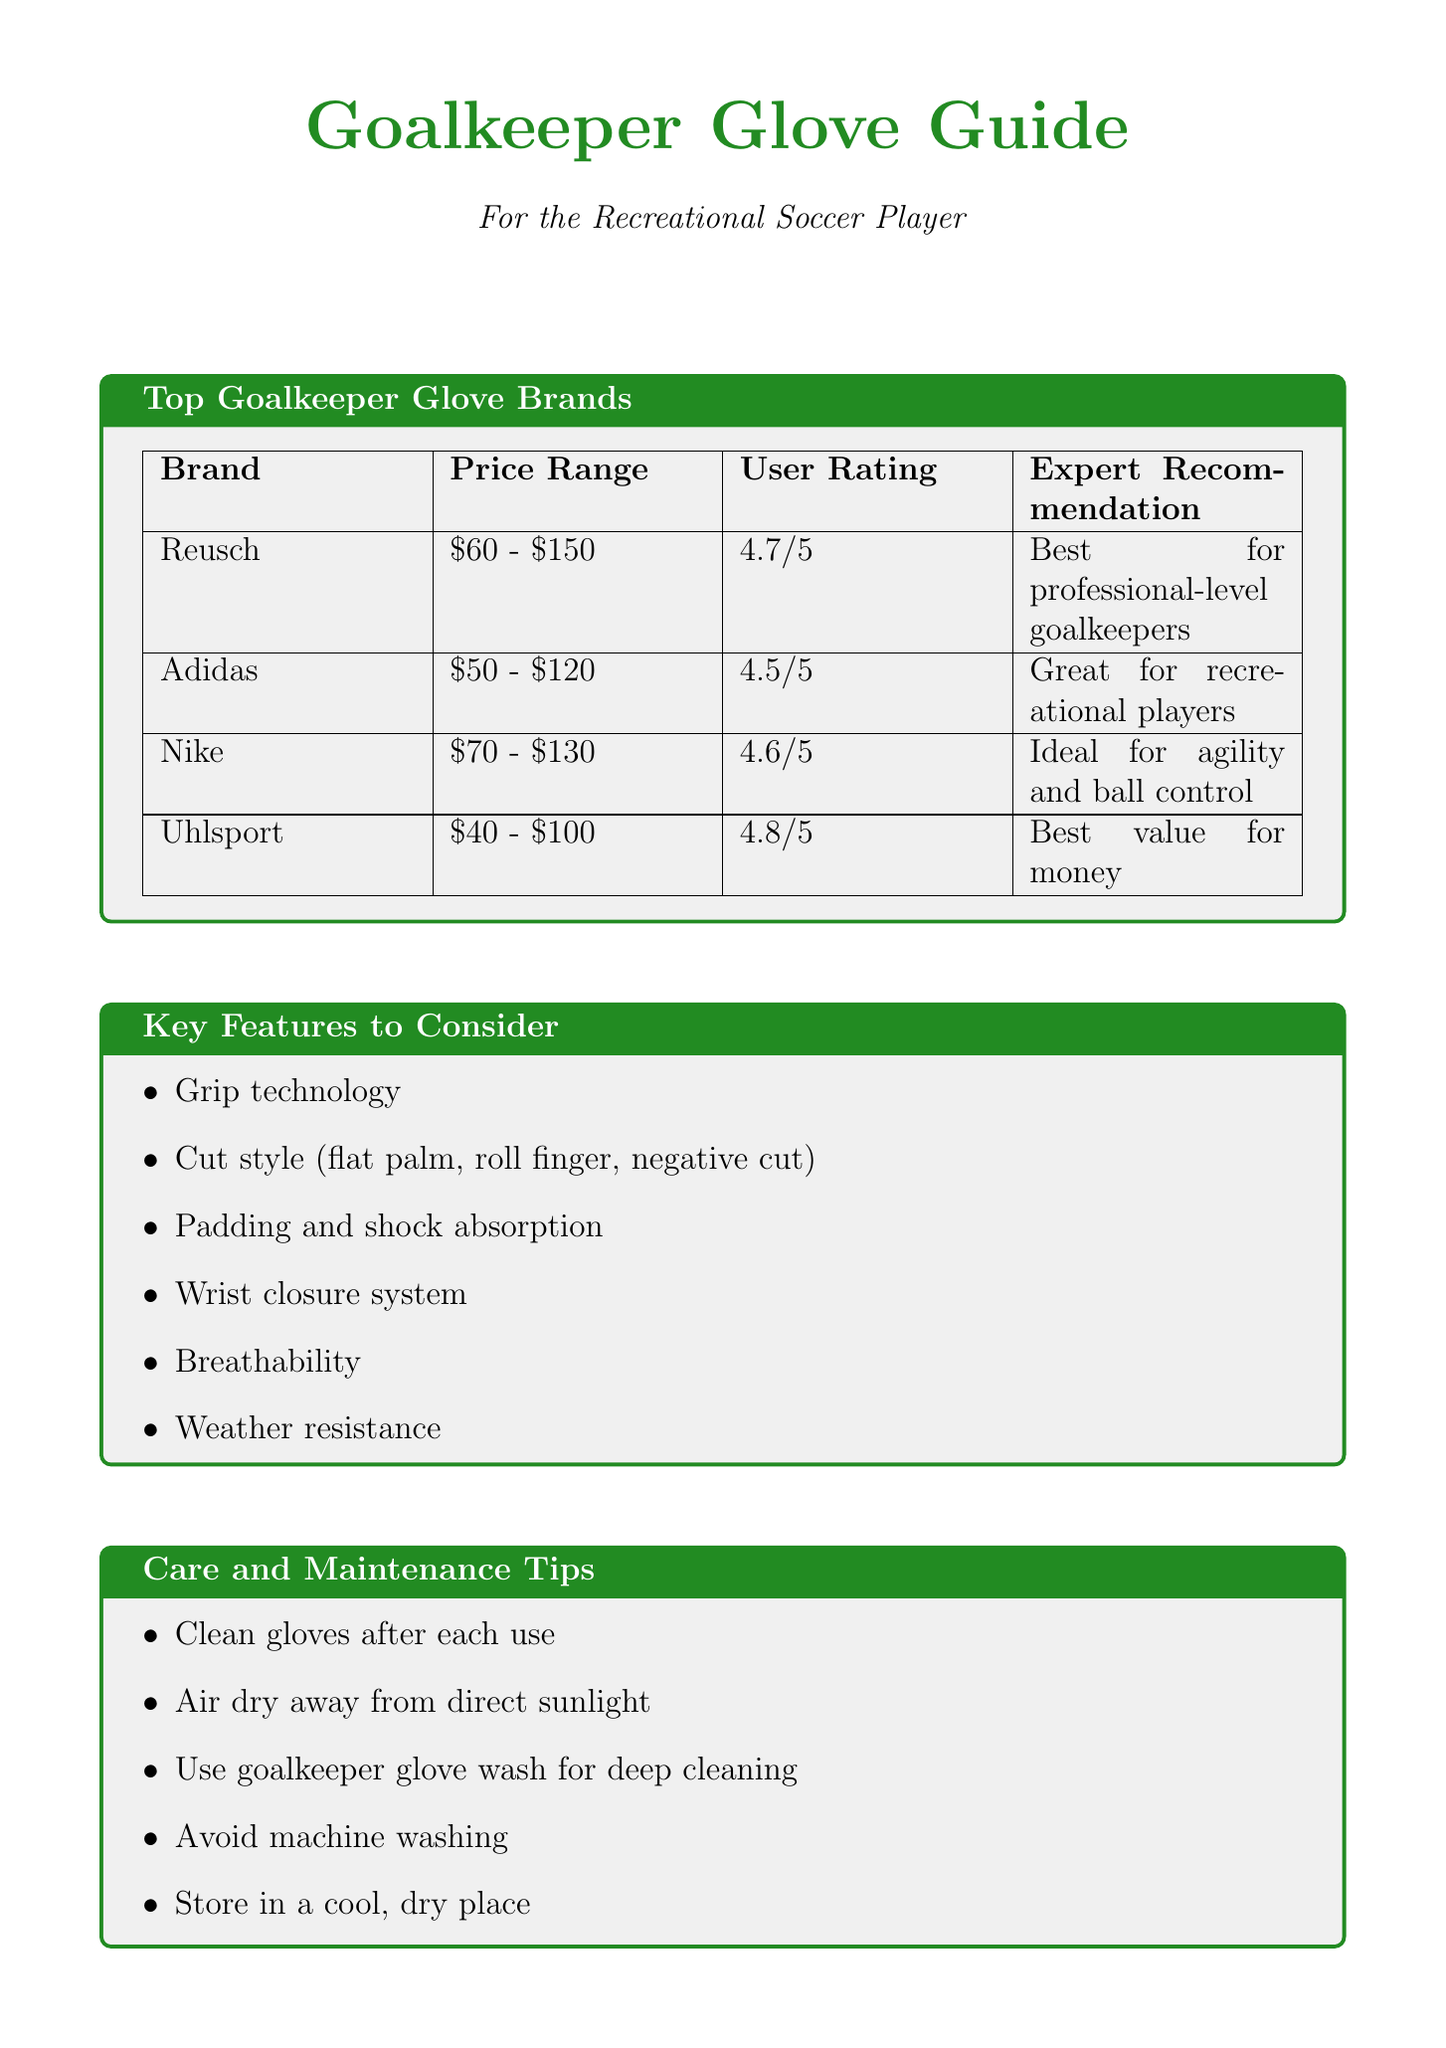What is the average rating of Uhlsport gloves? The average rating of Uhlsport gloves is 4.8.
Answer: 4.8 What is the price range of Adidas gloves? The price range of Adidas gloves is $50 - $120.
Answer: $50 - $120 Which brand is recommended for professional-level goalkeepers? Reusch is recommended for professional-level goalkeepers.
Answer: Reusch What common praise is mentioned for Nike gloves? The common praise for Nike gloves is that they are lightweight and flexible.
Answer: Lightweight and flexible What should you do after each use of goalkeeper gloves? You should clean gloves after each use.
Answer: Clean gloves after each use What is a myth about goalkeeper gloves related to pricing? A common myth is that more expensive gloves always perform better.
Answer: More expensive gloves always perform better Which brand provides the best value for money? Uhlsport provides the best value for money.
Answer: Uhlsport What factor should recreational players prioritize when choosing gloves? Recreational players should prioritize fit and feel when choosing gloves.
Answer: Fit and feel 